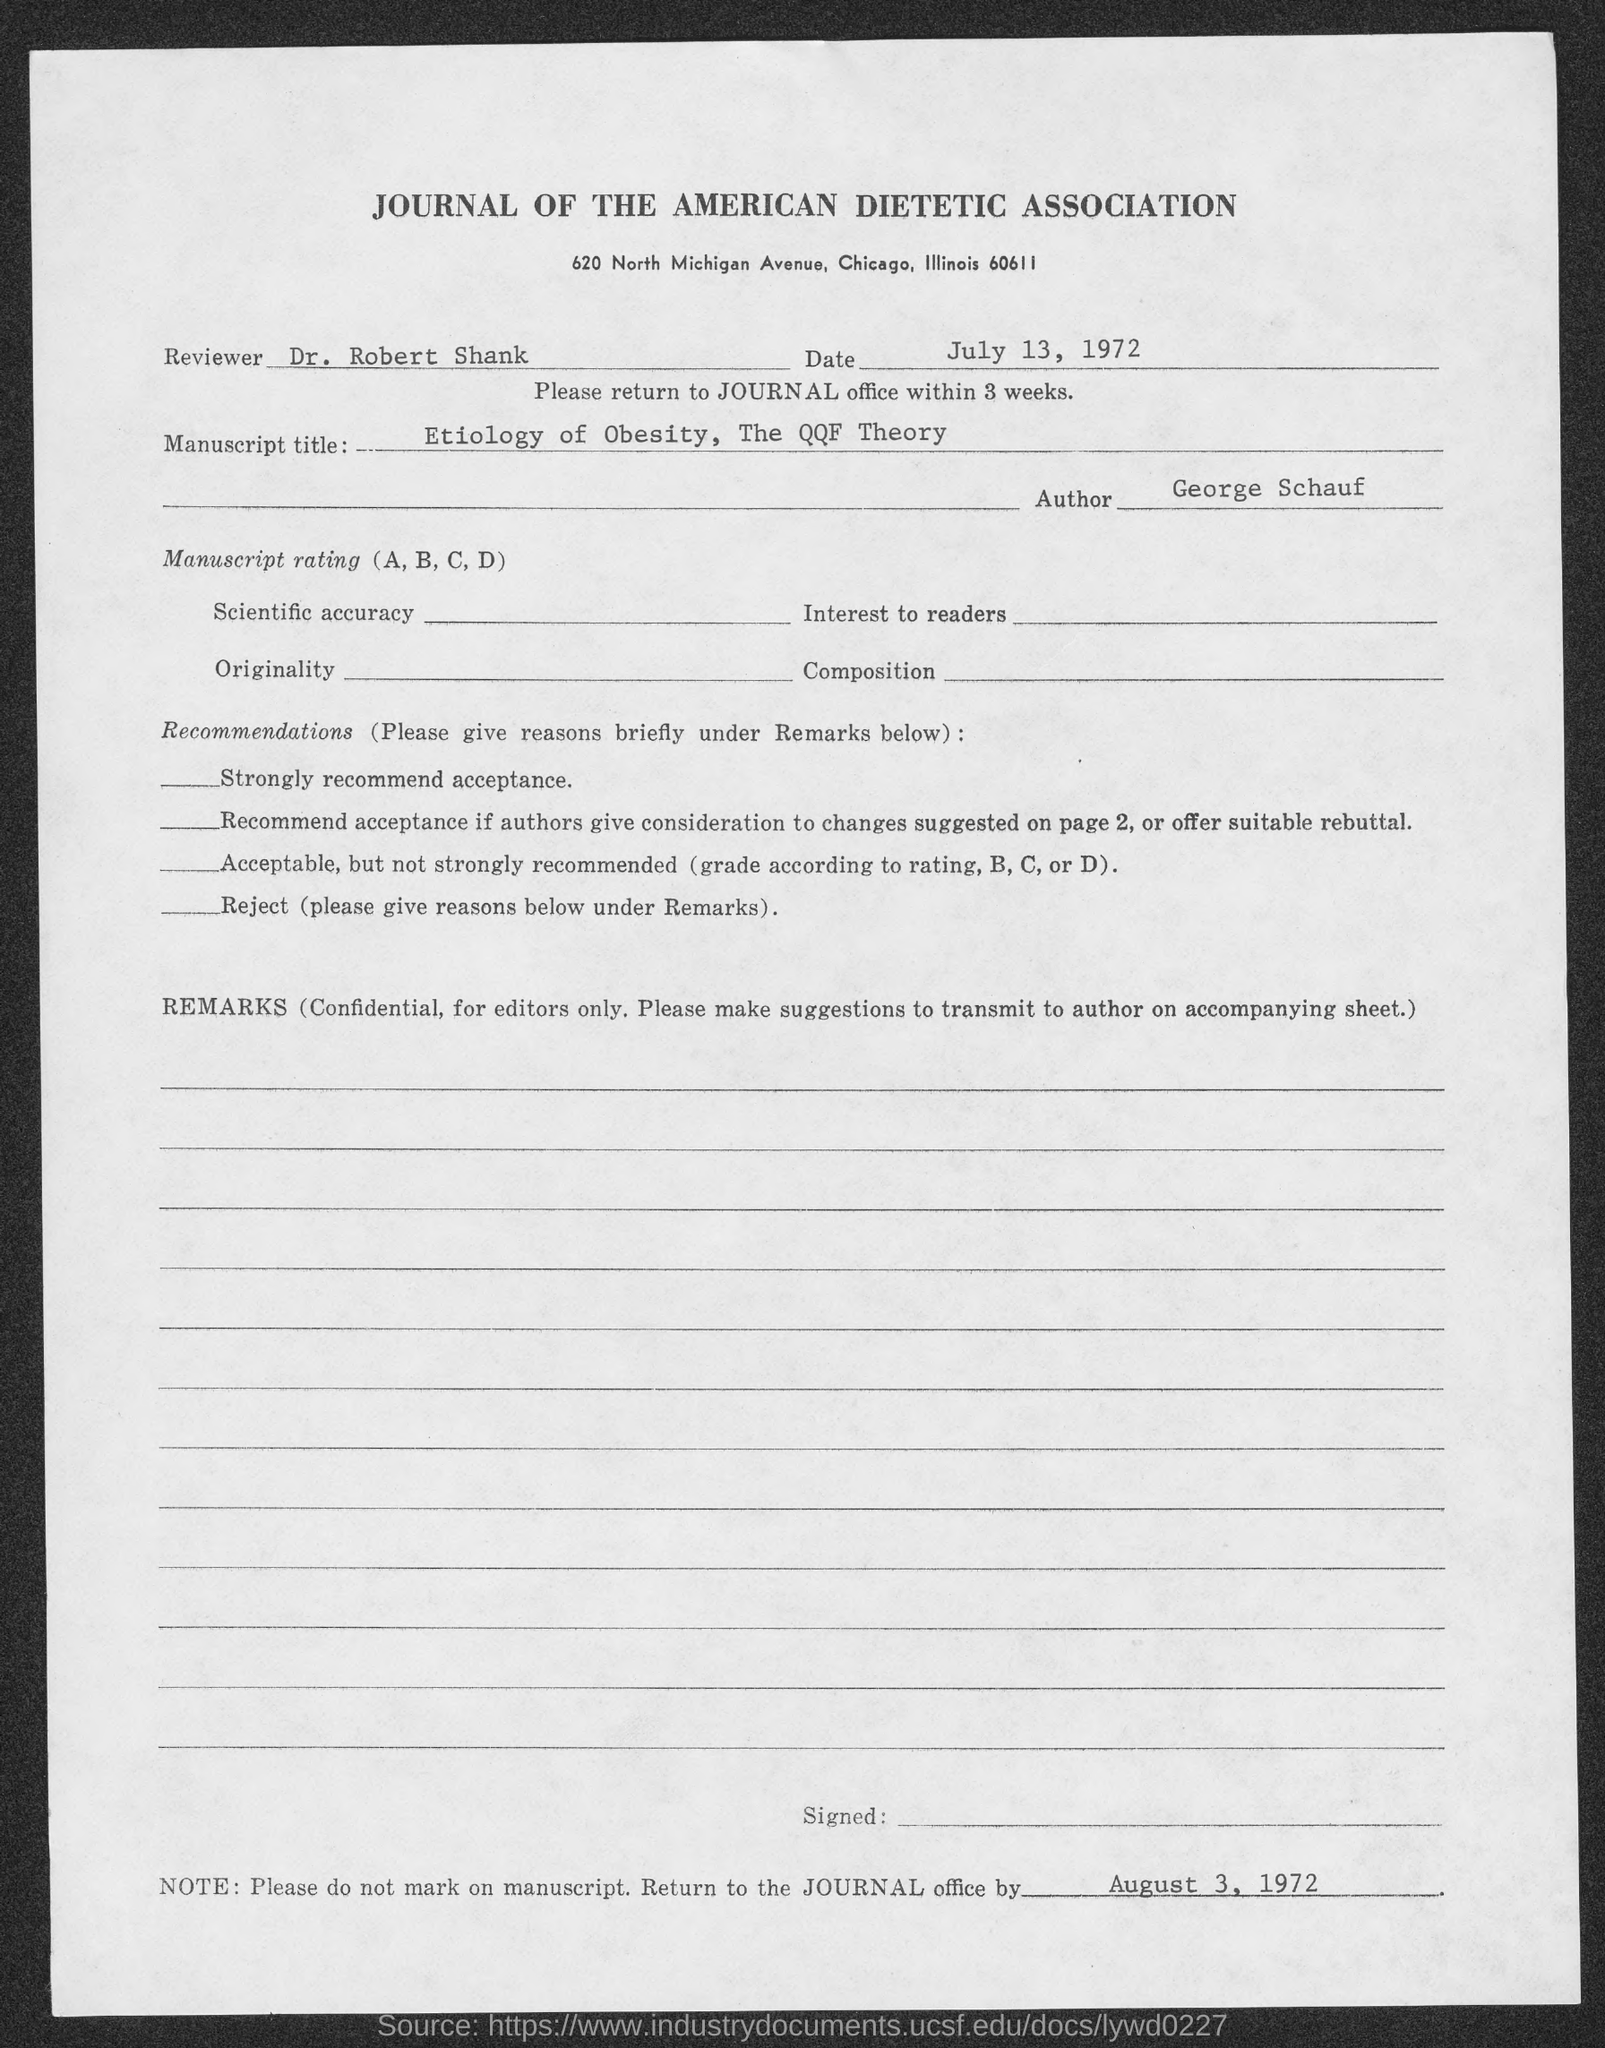Which Journal is mentioned in the header of the document?
Make the answer very short. JOURNAL OF THE AMERICAN DIETETIC ASSOCIATION. Who is the reviewer as per the document?
Your answer should be compact. DR. ROBERT SHANK. What is the issued date of this document?
Offer a terse response. July 13, 1972. What is the manuscript title mentioned in the document?
Offer a very short reply. ETIOLOGY OF OBESITY, THE QQF THEORY. Who is the author mentioned in the document?
Keep it short and to the point. George Schauf. 